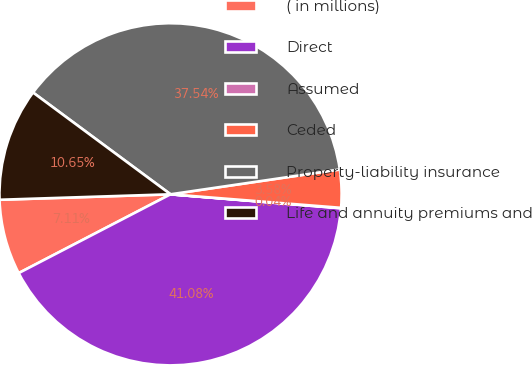<chart> <loc_0><loc_0><loc_500><loc_500><pie_chart><fcel>( in millions)<fcel>Direct<fcel>Assumed<fcel>Ceded<fcel>Property-liability insurance<fcel>Life and annuity premiums and<nl><fcel>7.11%<fcel>41.08%<fcel>0.04%<fcel>3.58%<fcel>37.54%<fcel>10.65%<nl></chart> 